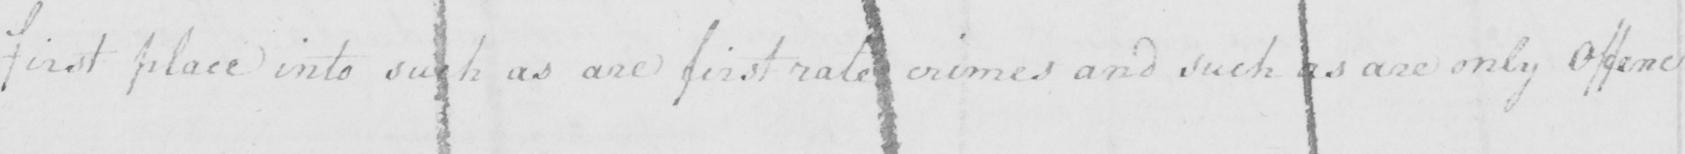What is written in this line of handwriting? first place into such as are first rate crimes and such as are only offenc= 